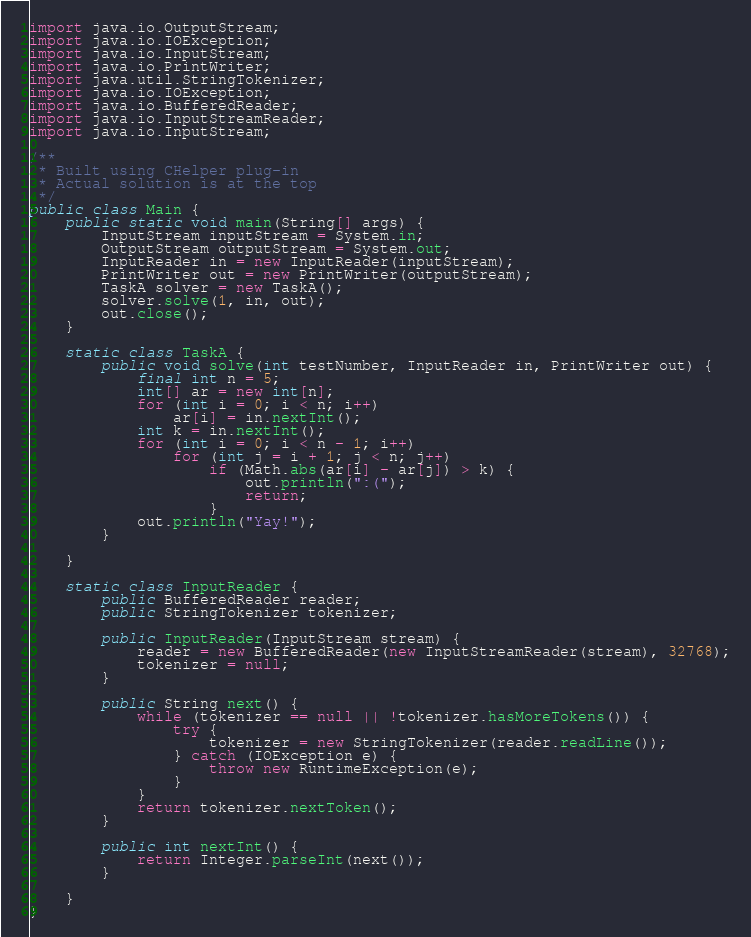<code> <loc_0><loc_0><loc_500><loc_500><_Java_>import java.io.OutputStream;
import java.io.IOException;
import java.io.InputStream;
import java.io.PrintWriter;
import java.util.StringTokenizer;
import java.io.IOException;
import java.io.BufferedReader;
import java.io.InputStreamReader;
import java.io.InputStream;

/**
 * Built using CHelper plug-in
 * Actual solution is at the top
 */
public class Main {
    public static void main(String[] args) {
        InputStream inputStream = System.in;
        OutputStream outputStream = System.out;
        InputReader in = new InputReader(inputStream);
        PrintWriter out = new PrintWriter(outputStream);
        TaskA solver = new TaskA();
        solver.solve(1, in, out);
        out.close();
    }

    static class TaskA {
        public void solve(int testNumber, InputReader in, PrintWriter out) {
            final int n = 5;
            int[] ar = new int[n];
            for (int i = 0; i < n; i++)
                ar[i] = in.nextInt();
            int k = in.nextInt();
            for (int i = 0; i < n - 1; i++)
                for (int j = i + 1; j < n; j++)
                    if (Math.abs(ar[i] - ar[j]) > k) {
                        out.println(":(");
                        return;
                    }
            out.println("Yay!");
        }

    }

    static class InputReader {
        public BufferedReader reader;
        public StringTokenizer tokenizer;

        public InputReader(InputStream stream) {
            reader = new BufferedReader(new InputStreamReader(stream), 32768);
            tokenizer = null;
        }

        public String next() {
            while (tokenizer == null || !tokenizer.hasMoreTokens()) {
                try {
                    tokenizer = new StringTokenizer(reader.readLine());
                } catch (IOException e) {
                    throw new RuntimeException(e);
                }
            }
            return tokenizer.nextToken();
        }

        public int nextInt() {
            return Integer.parseInt(next());
        }

    }
}</code> 